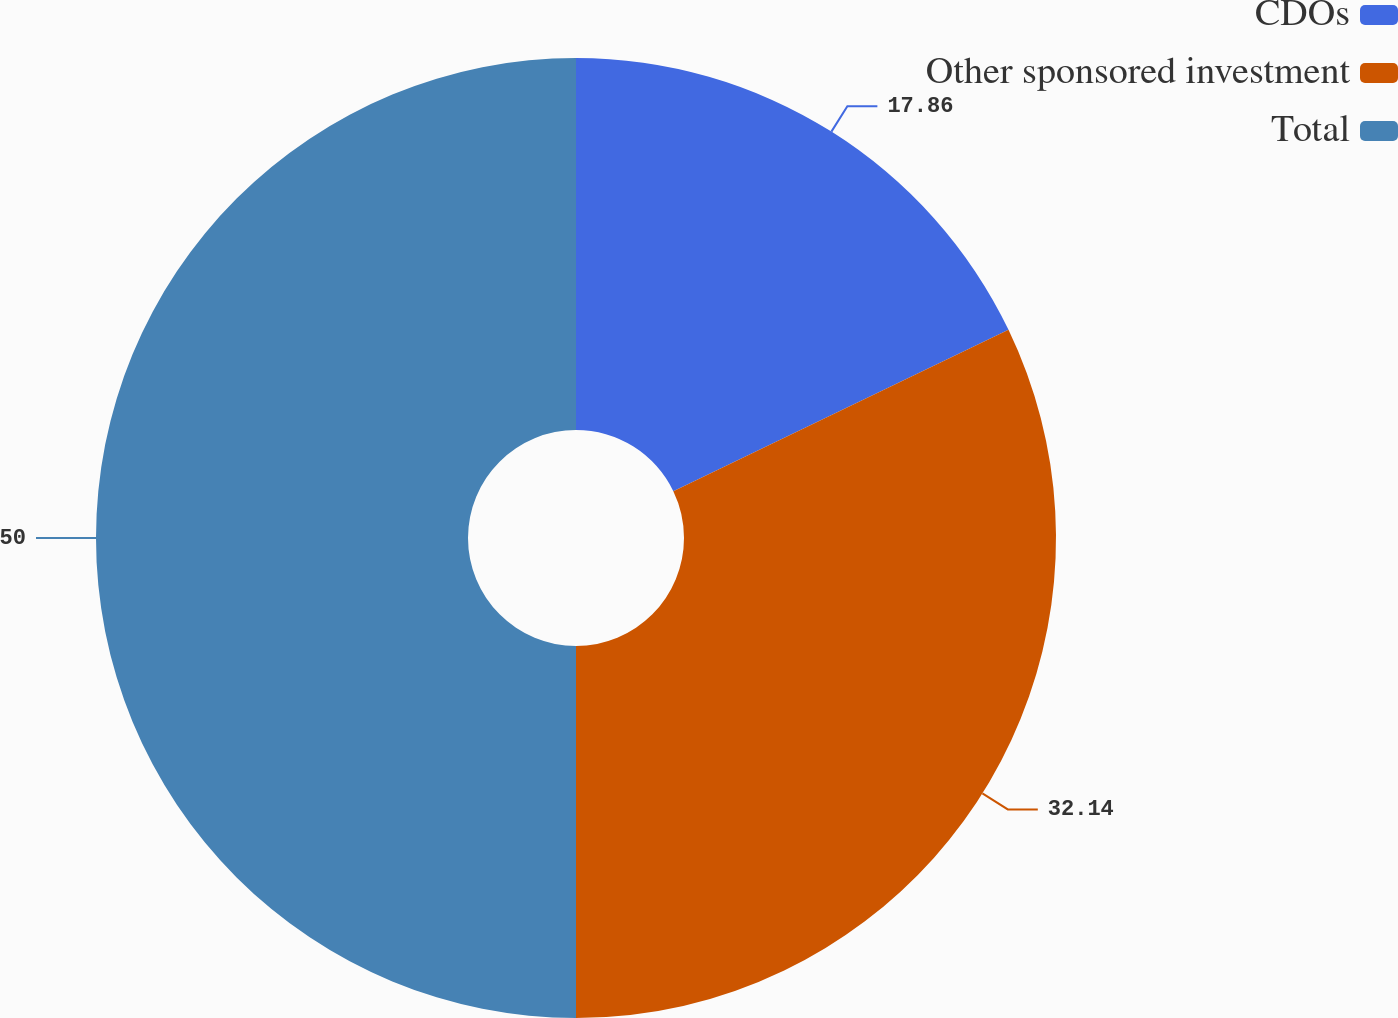Convert chart to OTSL. <chart><loc_0><loc_0><loc_500><loc_500><pie_chart><fcel>CDOs<fcel>Other sponsored investment<fcel>Total<nl><fcel>17.86%<fcel>32.14%<fcel>50.0%<nl></chart> 